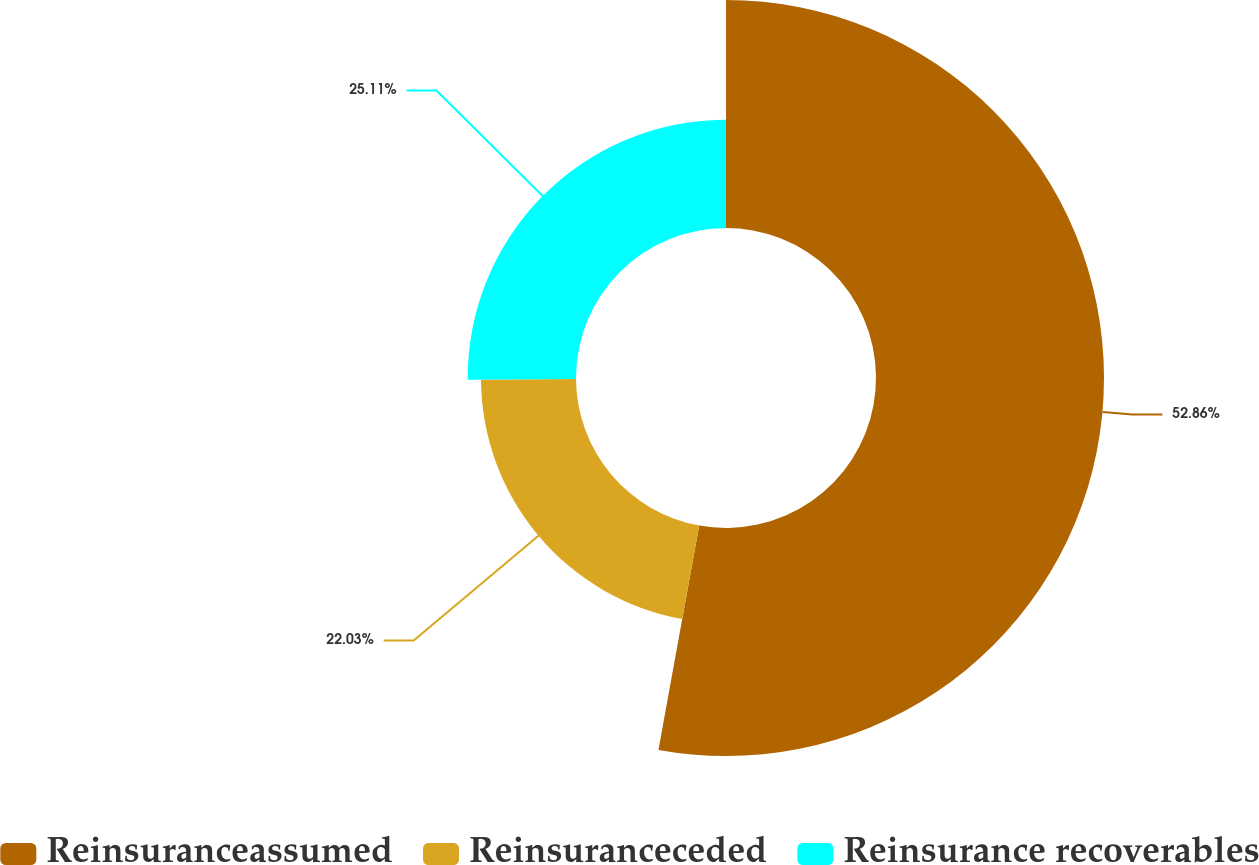<chart> <loc_0><loc_0><loc_500><loc_500><pie_chart><fcel>Reinsuranceassumed<fcel>Reinsuranceceded<fcel>Reinsurance recoverables<nl><fcel>52.86%<fcel>22.03%<fcel>25.11%<nl></chart> 